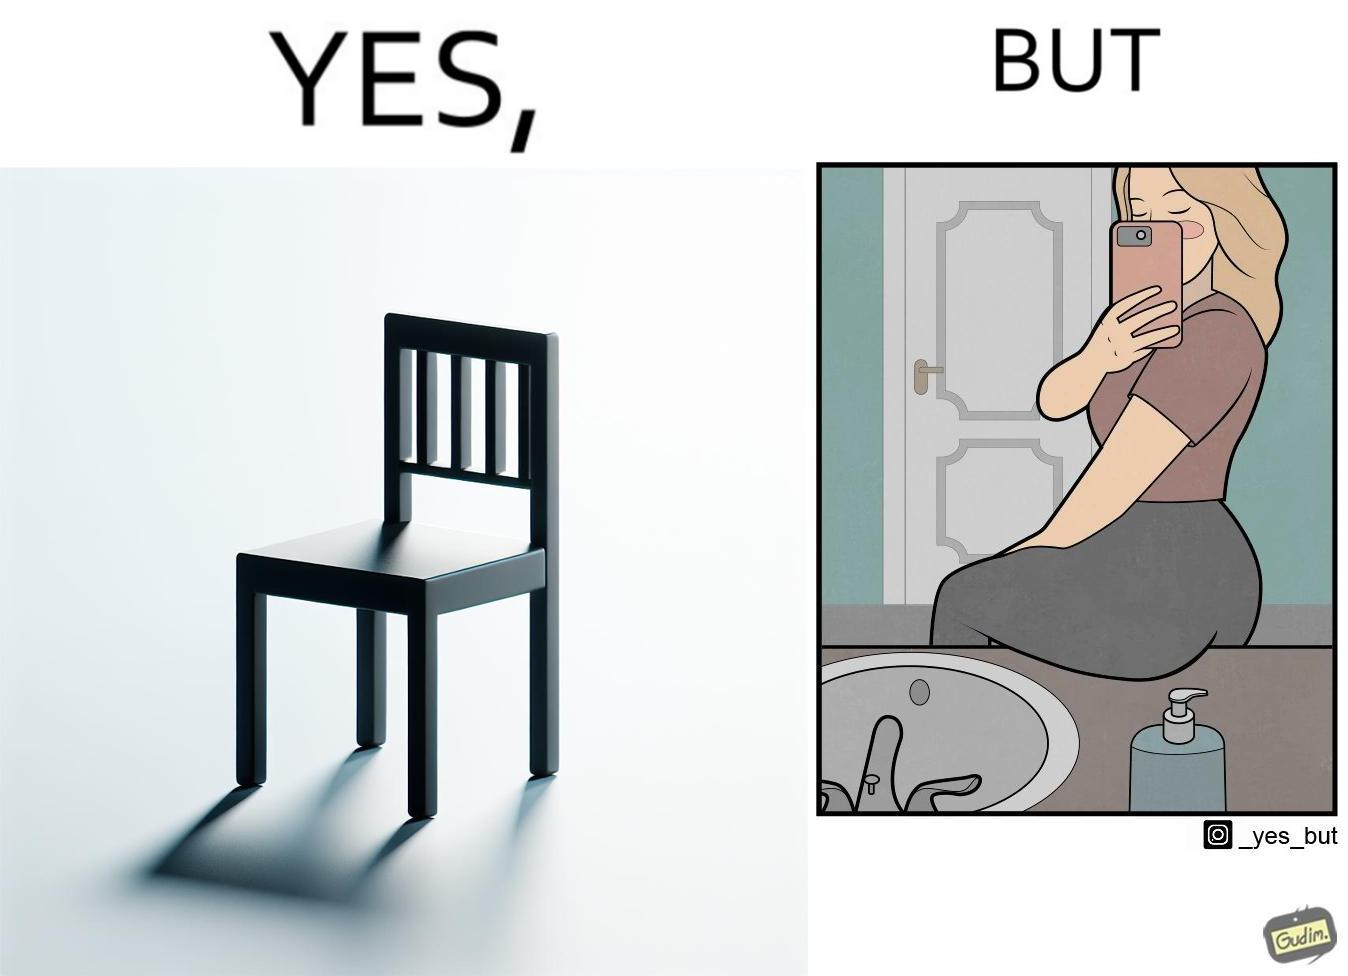What is shown in the left half versus the right half of this image? In the left part of the image: a chair. In the right part of the image: a woman sitting by the sink taking a selfie using a mirror. 